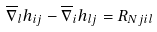Convert formula to latex. <formula><loc_0><loc_0><loc_500><loc_500>\overline { \nabla } _ { l } h _ { i j } - \overline { \nabla } _ { i } h _ { l j } = R _ { N j i l }</formula> 